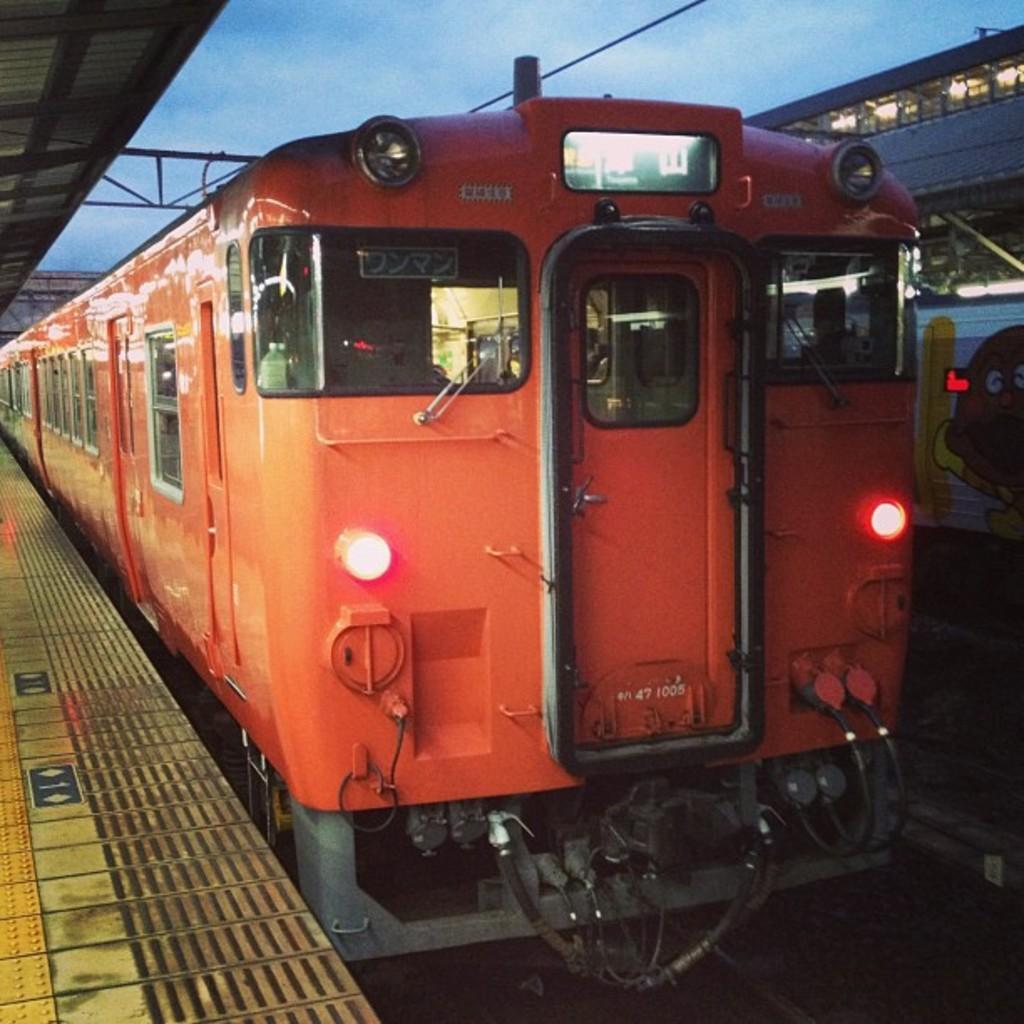How would you summarize this image in a sentence or two? In this image I can see the trains on the track. I can see the lights to the trains. To the left I can see the platform. In the background I can see the sky. 